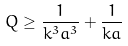<formula> <loc_0><loc_0><loc_500><loc_500>Q \geq \frac { 1 } { k ^ { 3 } a ^ { 3 } } + \frac { 1 } { k a }</formula> 